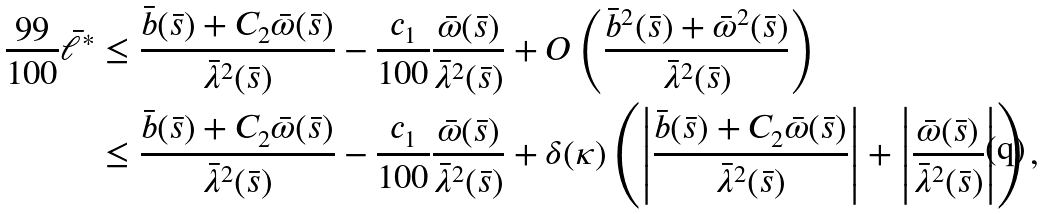<formula> <loc_0><loc_0><loc_500><loc_500>\frac { 9 9 } { 1 0 0 } \bar { \ell } ^ { * } & \leq \frac { \bar { b } ( \bar { s } ) + C _ { 2 } \bar { \omega } ( \bar { s } ) } { \bar { \lambda } ^ { 2 } ( \bar { s } ) } - \frac { c _ { 1 } } { 1 0 0 } \frac { \bar { \omega } ( \bar { s } ) } { \bar { \lambda } ^ { 2 } ( \bar { s } ) } + O \left ( \frac { \bar { b } ^ { 2 } ( \bar { s } ) + \bar { \omega } ^ { 2 } ( \bar { s } ) } { \bar { \lambda } ^ { 2 } ( \bar { s } ) } \right ) \\ & \leq \frac { \bar { b } ( \bar { s } ) + C _ { 2 } \bar { \omega } ( \bar { s } ) } { \bar { \lambda } ^ { 2 } ( \bar { s } ) } - \frac { c _ { 1 } } { 1 0 0 } \frac { \bar { \omega } ( \bar { s } ) } { \bar { \lambda } ^ { 2 } ( \bar { s } ) } + \delta ( \kappa ) \left ( \left | \frac { \bar { b } ( \bar { s } ) + C _ { 2 } \bar { \omega } ( \bar { s } ) } { \bar { \lambda } ^ { 2 } ( \bar { s } ) } \right | + \left | \frac { \bar { \omega } ( \bar { s } ) } { \bar { \lambda } ^ { 2 } ( \bar { s } ) } \right | \right ) ,</formula> 